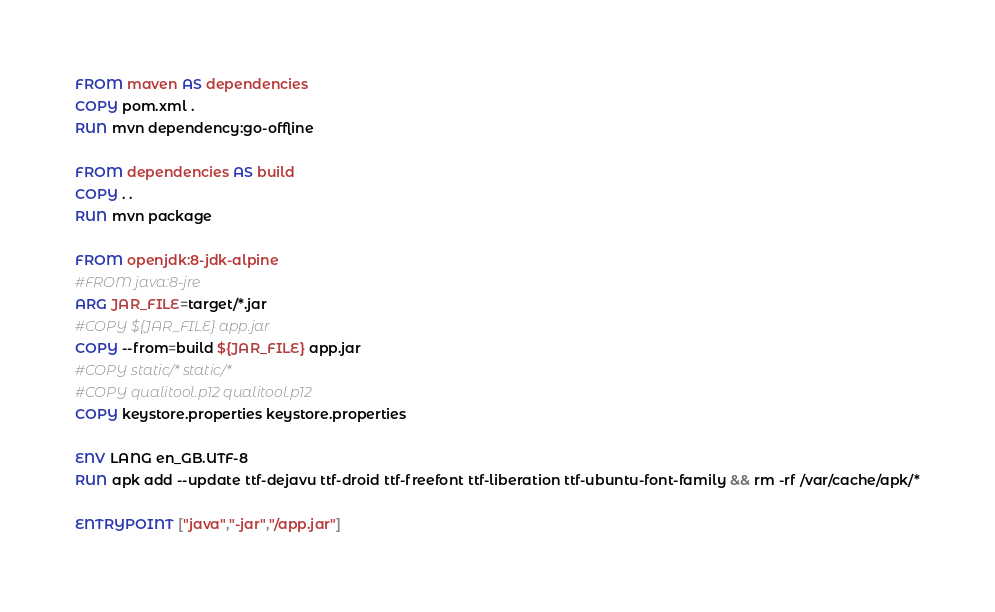Convert code to text. <code><loc_0><loc_0><loc_500><loc_500><_Dockerfile_>FROM maven AS dependencies
COPY pom.xml .
RUN mvn dependency:go-offline

FROM dependencies AS build
COPY . .
RUN mvn package

FROM openjdk:8-jdk-alpine
#FROM java:8-jre
ARG JAR_FILE=target/*.jar
#COPY ${JAR_FILE} app.jar
COPY --from=build ${JAR_FILE} app.jar
#COPY static/* static/*
#COPY qualitool.p12 qualitool.p12
COPY keystore.properties keystore.properties

ENV LANG en_GB.UTF-8
RUN apk add --update ttf-dejavu ttf-droid ttf-freefont ttf-liberation ttf-ubuntu-font-family && rm -rf /var/cache/apk/*

ENTRYPOINT ["java","-jar","/app.jar"]</code> 